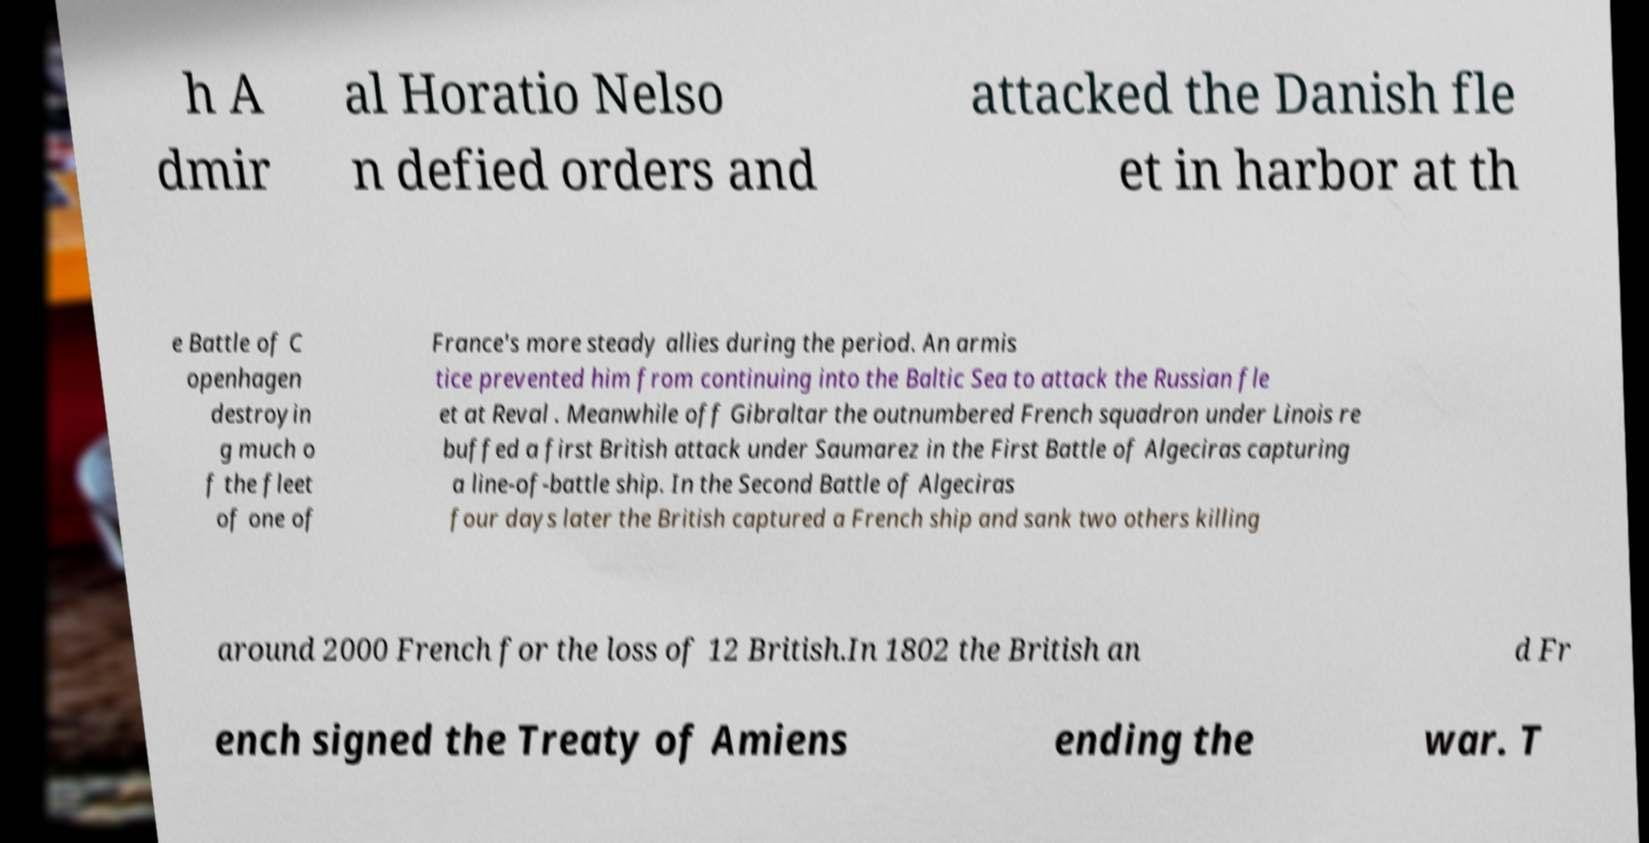Could you extract and type out the text from this image? h A dmir al Horatio Nelso n defied orders and attacked the Danish fle et in harbor at th e Battle of C openhagen destroyin g much o f the fleet of one of France's more steady allies during the period. An armis tice prevented him from continuing into the Baltic Sea to attack the Russian fle et at Reval . Meanwhile off Gibraltar the outnumbered French squadron under Linois re buffed a first British attack under Saumarez in the First Battle of Algeciras capturing a line-of-battle ship. In the Second Battle of Algeciras four days later the British captured a French ship and sank two others killing around 2000 French for the loss of 12 British.In 1802 the British an d Fr ench signed the Treaty of Amiens ending the war. T 